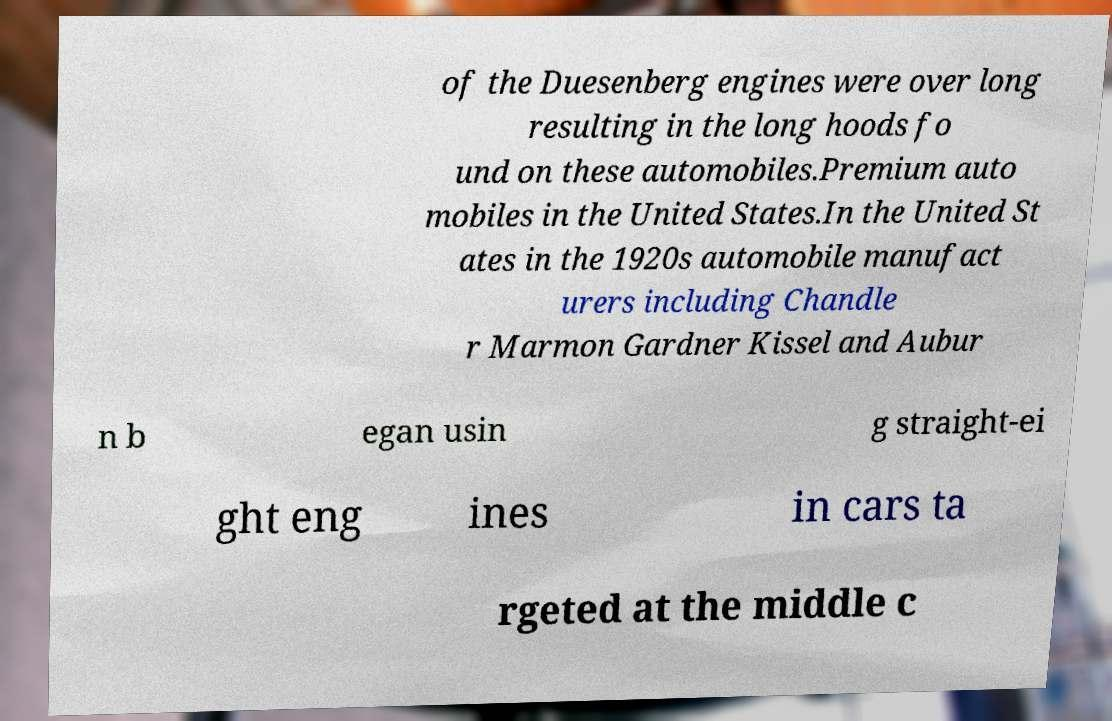What messages or text are displayed in this image? I need them in a readable, typed format. of the Duesenberg engines were over long resulting in the long hoods fo und on these automobiles.Premium auto mobiles in the United States.In the United St ates in the 1920s automobile manufact urers including Chandle r Marmon Gardner Kissel and Aubur n b egan usin g straight-ei ght eng ines in cars ta rgeted at the middle c 